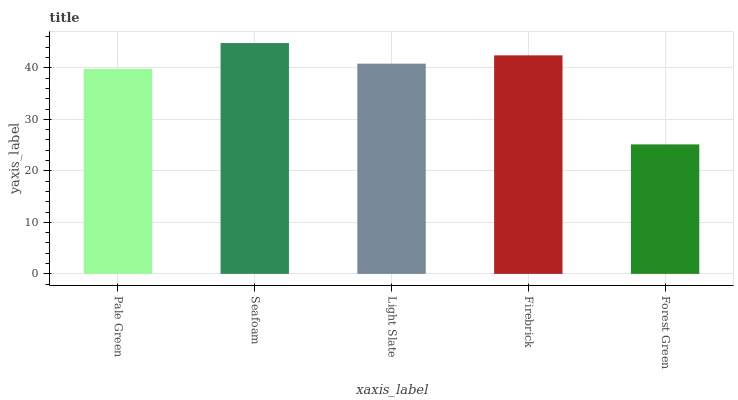Is Forest Green the minimum?
Answer yes or no. Yes. Is Seafoam the maximum?
Answer yes or no. Yes. Is Light Slate the minimum?
Answer yes or no. No. Is Light Slate the maximum?
Answer yes or no. No. Is Seafoam greater than Light Slate?
Answer yes or no. Yes. Is Light Slate less than Seafoam?
Answer yes or no. Yes. Is Light Slate greater than Seafoam?
Answer yes or no. No. Is Seafoam less than Light Slate?
Answer yes or no. No. Is Light Slate the high median?
Answer yes or no. Yes. Is Light Slate the low median?
Answer yes or no. Yes. Is Pale Green the high median?
Answer yes or no. No. Is Forest Green the low median?
Answer yes or no. No. 